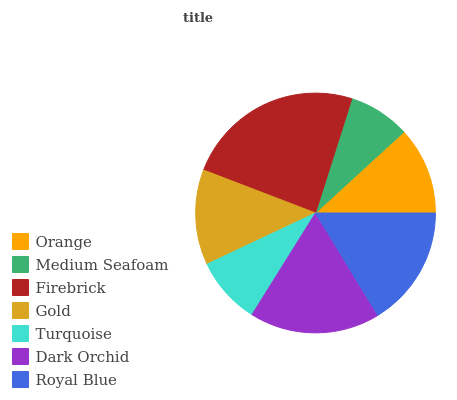Is Medium Seafoam the minimum?
Answer yes or no. Yes. Is Firebrick the maximum?
Answer yes or no. Yes. Is Firebrick the minimum?
Answer yes or no. No. Is Medium Seafoam the maximum?
Answer yes or no. No. Is Firebrick greater than Medium Seafoam?
Answer yes or no. Yes. Is Medium Seafoam less than Firebrick?
Answer yes or no. Yes. Is Medium Seafoam greater than Firebrick?
Answer yes or no. No. Is Firebrick less than Medium Seafoam?
Answer yes or no. No. Is Gold the high median?
Answer yes or no. Yes. Is Gold the low median?
Answer yes or no. Yes. Is Orange the high median?
Answer yes or no. No. Is Dark Orchid the low median?
Answer yes or no. No. 